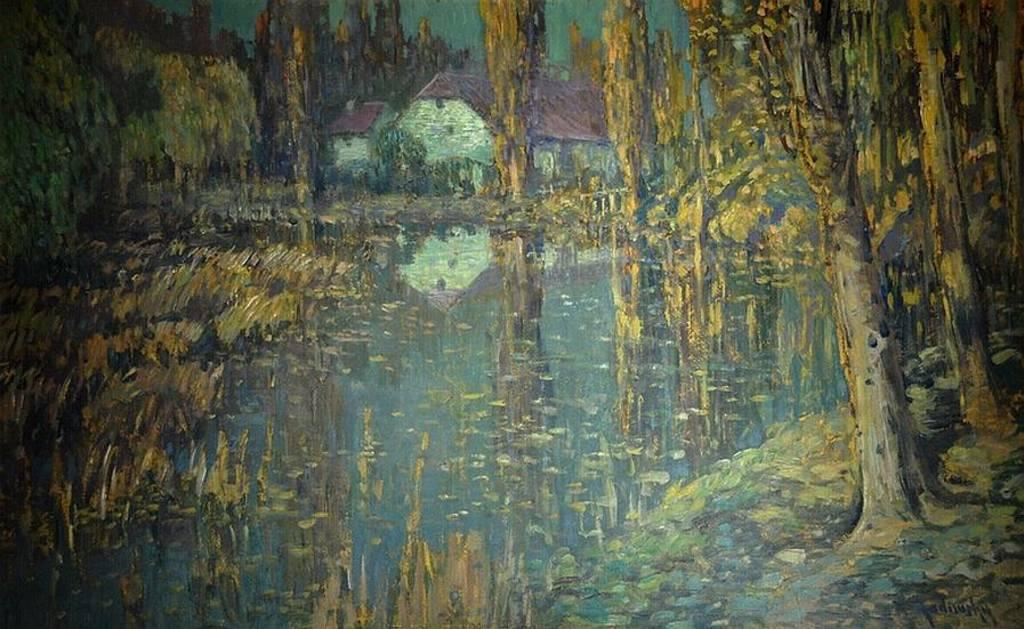What is featured in the wall painting in the image? The wall painting depicts a house, water, and trees. Can you describe the main subject of the wall painting? The main subject of the wall painting is a house. What other elements are present in the wall painting besides the house? The wall painting also depicts water and trees. How many cows are visible in the wall painting? There are no cows depicted in the wall painting; it features a house, water, and trees. What type of quarter is shown in the wall painting? There is no quarter depicted in the wall painting; it features a house, water, and trees. 